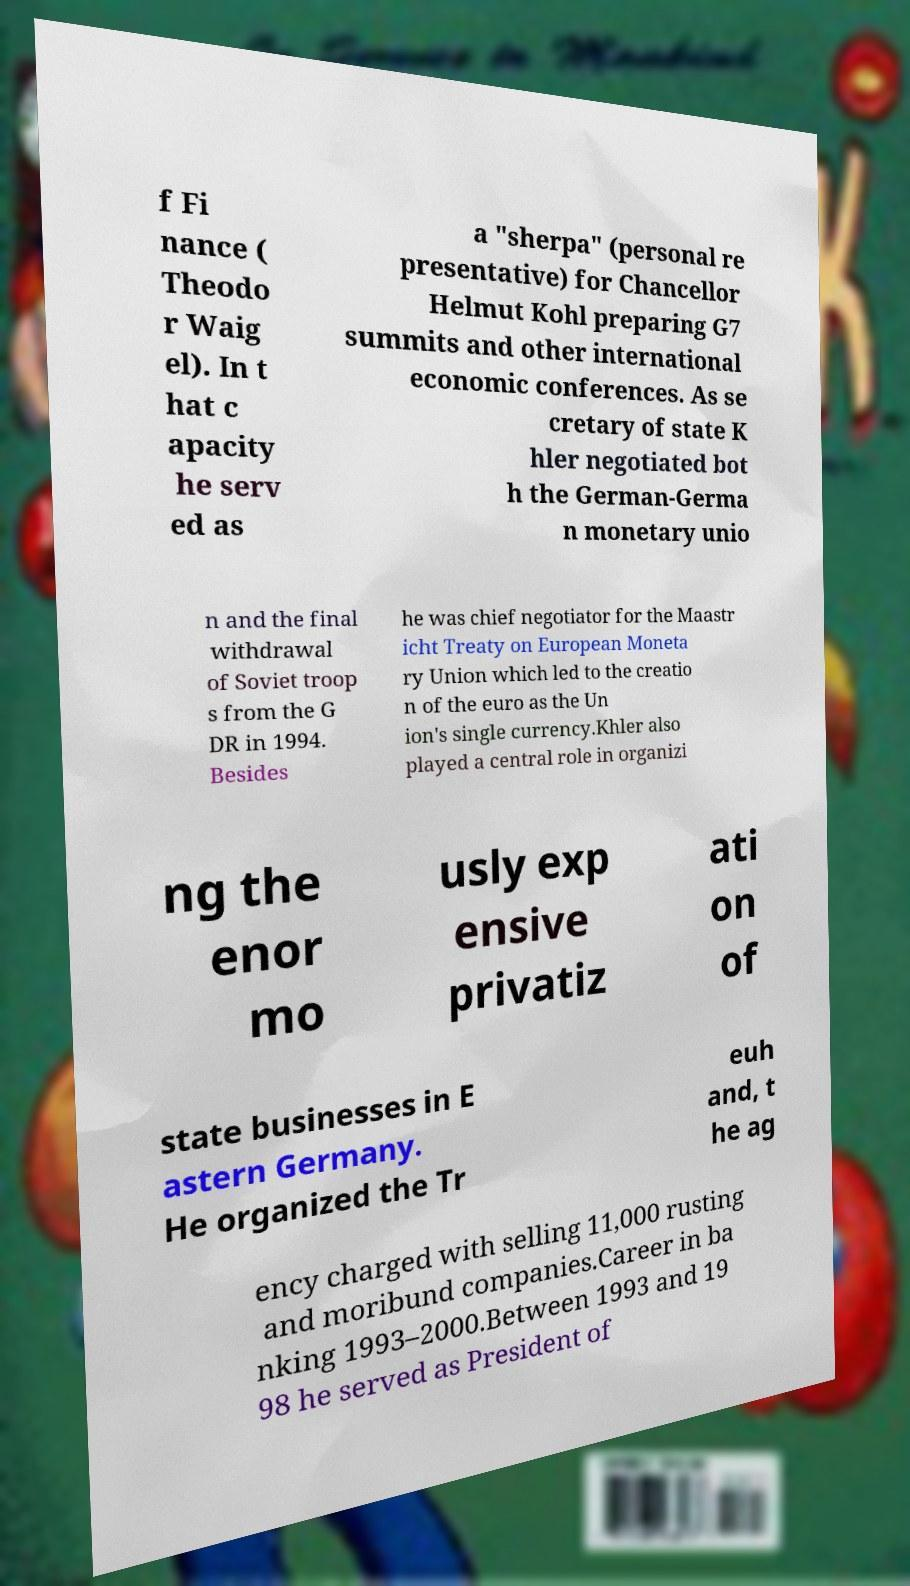For documentation purposes, I need the text within this image transcribed. Could you provide that? f Fi nance ( Theodo r Waig el). In t hat c apacity he serv ed as a "sherpa" (personal re presentative) for Chancellor Helmut Kohl preparing G7 summits and other international economic conferences. As se cretary of state K hler negotiated bot h the German-Germa n monetary unio n and the final withdrawal of Soviet troop s from the G DR in 1994. Besides he was chief negotiator for the Maastr icht Treaty on European Moneta ry Union which led to the creatio n of the euro as the Un ion's single currency.Khler also played a central role in organizi ng the enor mo usly exp ensive privatiz ati on of state businesses in E astern Germany. He organized the Tr euh and, t he ag ency charged with selling 11,000 rusting and moribund companies.Career in ba nking 1993–2000.Between 1993 and 19 98 he served as President of 